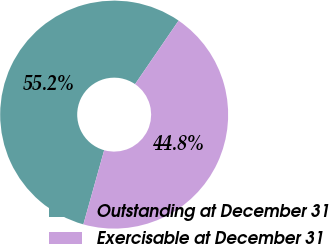Convert chart to OTSL. <chart><loc_0><loc_0><loc_500><loc_500><pie_chart><fcel>Outstanding at December 31<fcel>Exercisable at December 31<nl><fcel>55.21%<fcel>44.79%<nl></chart> 